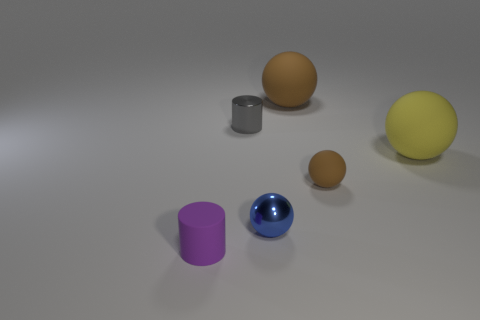Subtract all tiny rubber balls. How many balls are left? 3 Add 2 big brown matte objects. How many objects exist? 8 Subtract all balls. How many objects are left? 2 Subtract 3 balls. How many balls are left? 1 Subtract all yellow balls. How many balls are left? 3 Subtract all brown cylinders. Subtract all gray balls. How many cylinders are left? 2 Subtract all green cubes. How many gray balls are left? 0 Subtract all big rubber things. Subtract all rubber objects. How many objects are left? 0 Add 6 gray objects. How many gray objects are left? 7 Add 4 small purple cylinders. How many small purple cylinders exist? 5 